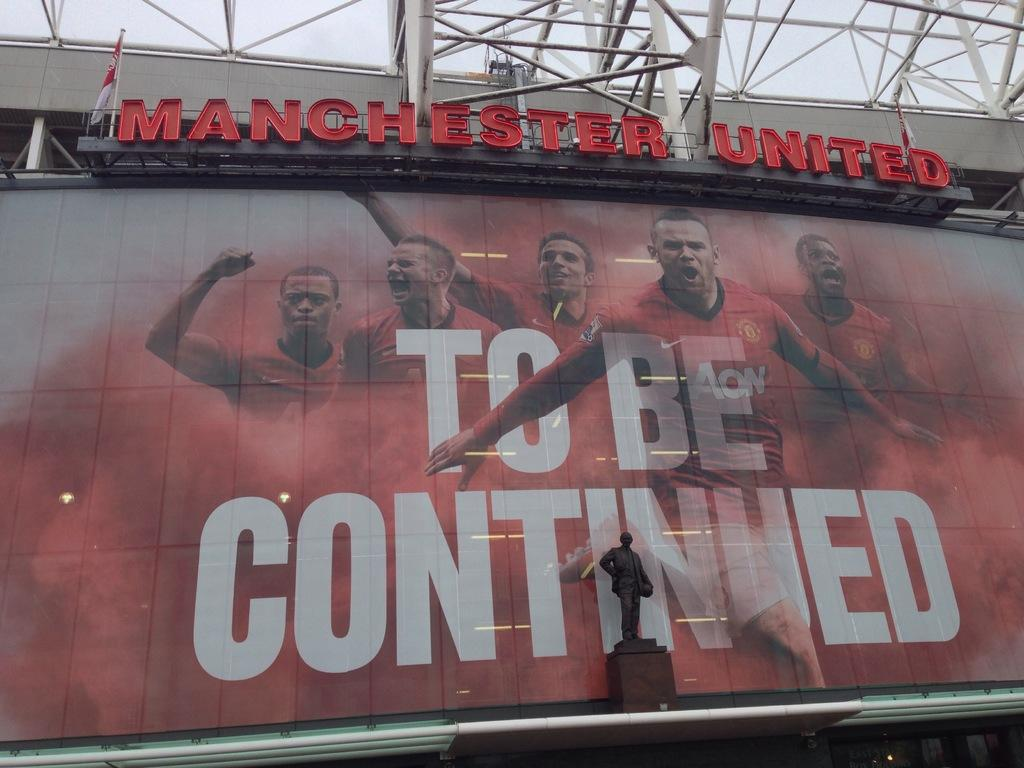<image>
Summarize the visual content of the image. a sign that says 'to be continued' on it 